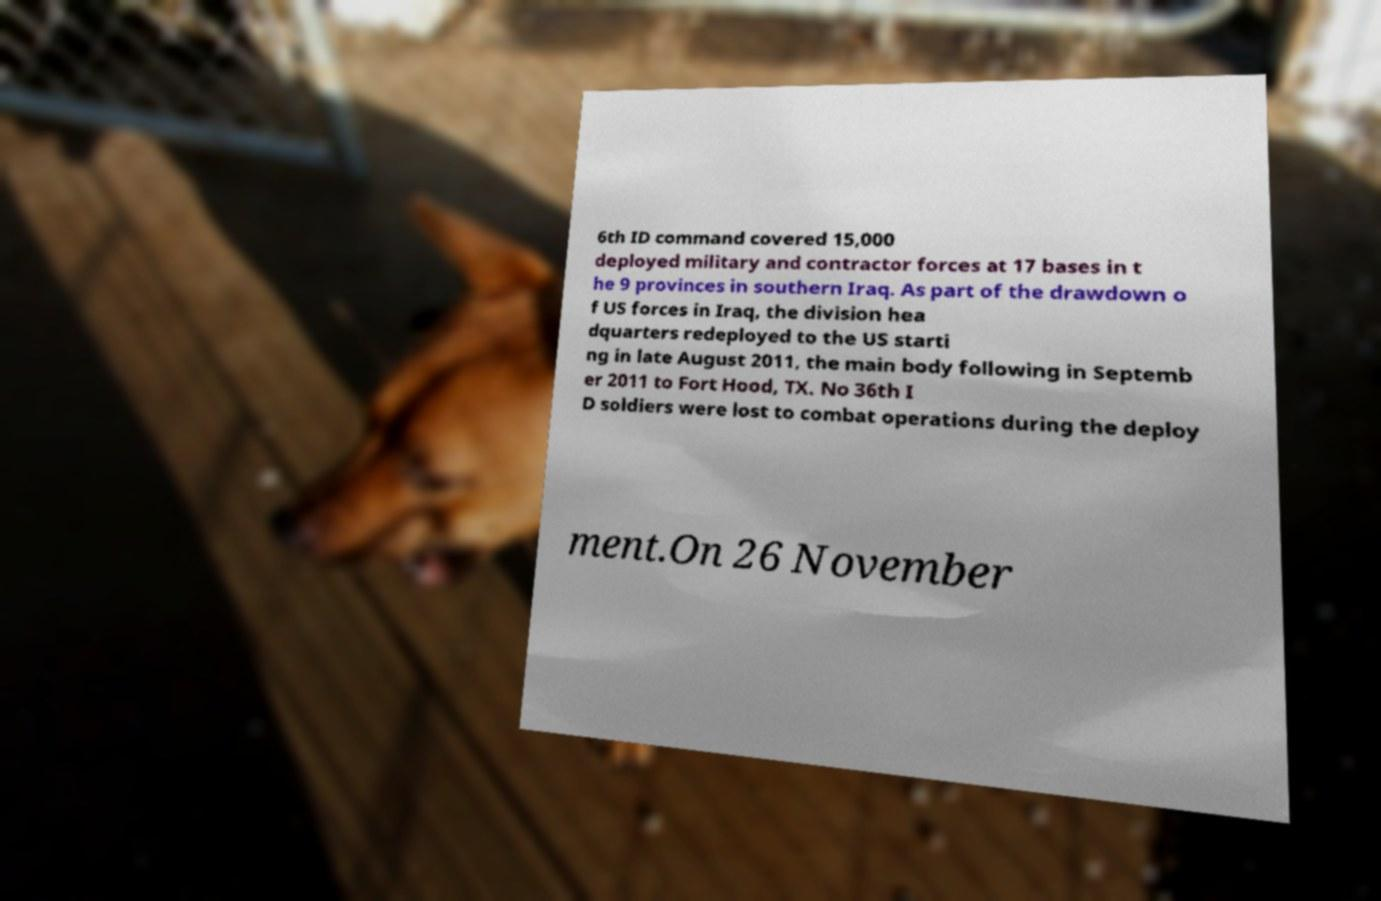What messages or text are displayed in this image? I need them in a readable, typed format. 6th ID command covered 15,000 deployed military and contractor forces at 17 bases in t he 9 provinces in southern Iraq. As part of the drawdown o f US forces in Iraq, the division hea dquarters redeployed to the US starti ng in late August 2011, the main body following in Septemb er 2011 to Fort Hood, TX. No 36th I D soldiers were lost to combat operations during the deploy ment.On 26 November 